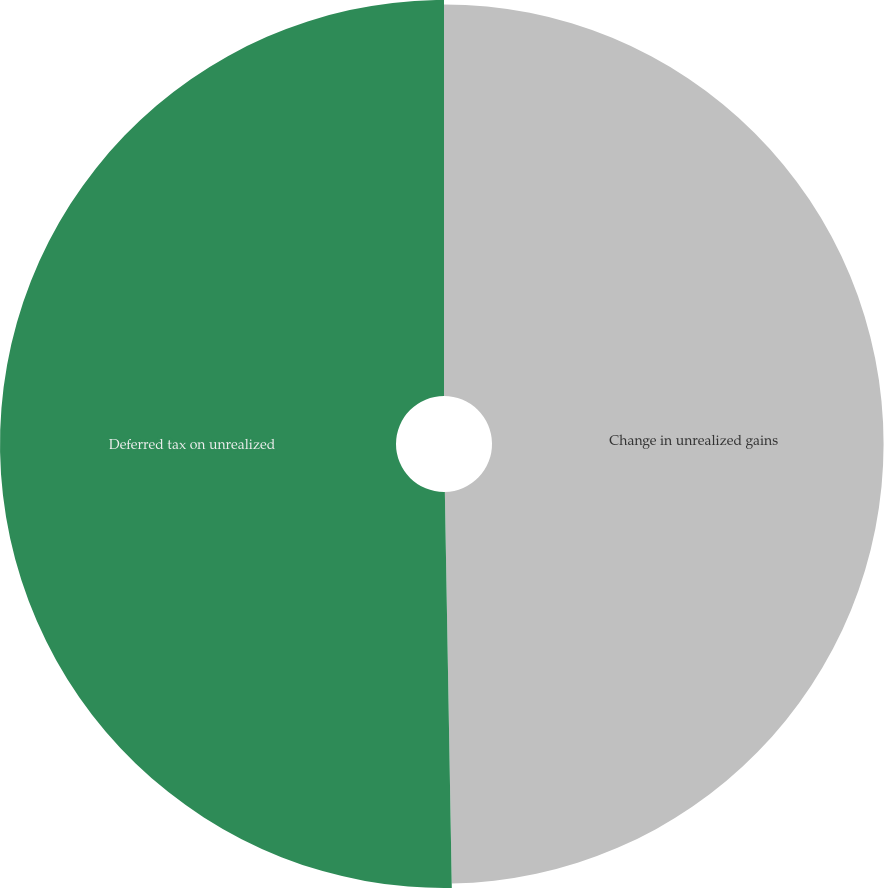Convert chart. <chart><loc_0><loc_0><loc_500><loc_500><pie_chart><fcel>Change in unrealized gains<fcel>Deferred tax on unrealized<nl><fcel>49.72%<fcel>50.28%<nl></chart> 